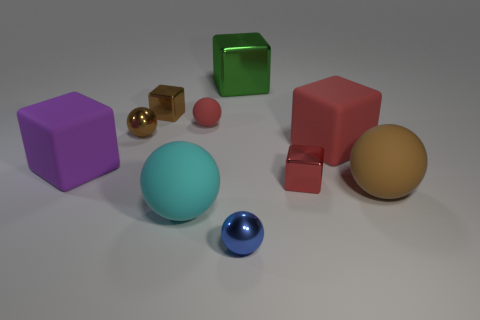Are there any other big metallic objects that have the same shape as the big metallic object?
Provide a succinct answer. No. What is the shape of the red metallic thing?
Offer a terse response. Cube. How many objects are either large gray cylinders or blue things?
Offer a very short reply. 1. There is a metal sphere that is behind the large purple cube; is its size the same as the cube to the left of the small brown metallic block?
Make the answer very short. No. How many other objects are there of the same material as the brown cube?
Give a very brief answer. 4. Are there more big metal things that are right of the big purple matte block than blue objects behind the red matte ball?
Make the answer very short. Yes. What material is the tiny red object that is behind the purple matte object?
Offer a very short reply. Rubber. Does the purple rubber object have the same shape as the green thing?
Your answer should be very brief. Yes. Are there any other things of the same color as the large metallic cube?
Make the answer very short. No. What color is the tiny matte thing that is the same shape as the small blue metallic object?
Your answer should be compact. Red. 